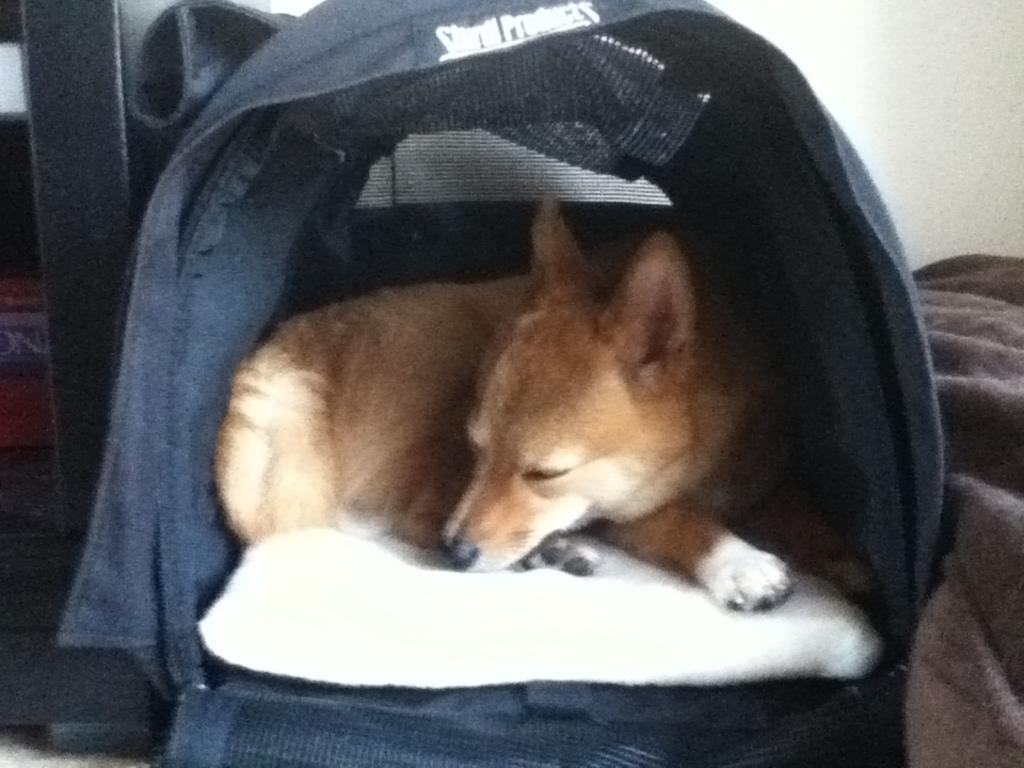What type of animal is in the image? There is a dog in the image. Where is the dog located? The dog is in a pet bed. What can be seen on the right side of the image? There is a bed sheet on the right side of the image. What is visible in the background of the image? There is a wall in the background of the image. What type of wine is being served in the image? There is no wine present in the image; it features a dog in a pet bed and a bed sheet on the right side. 